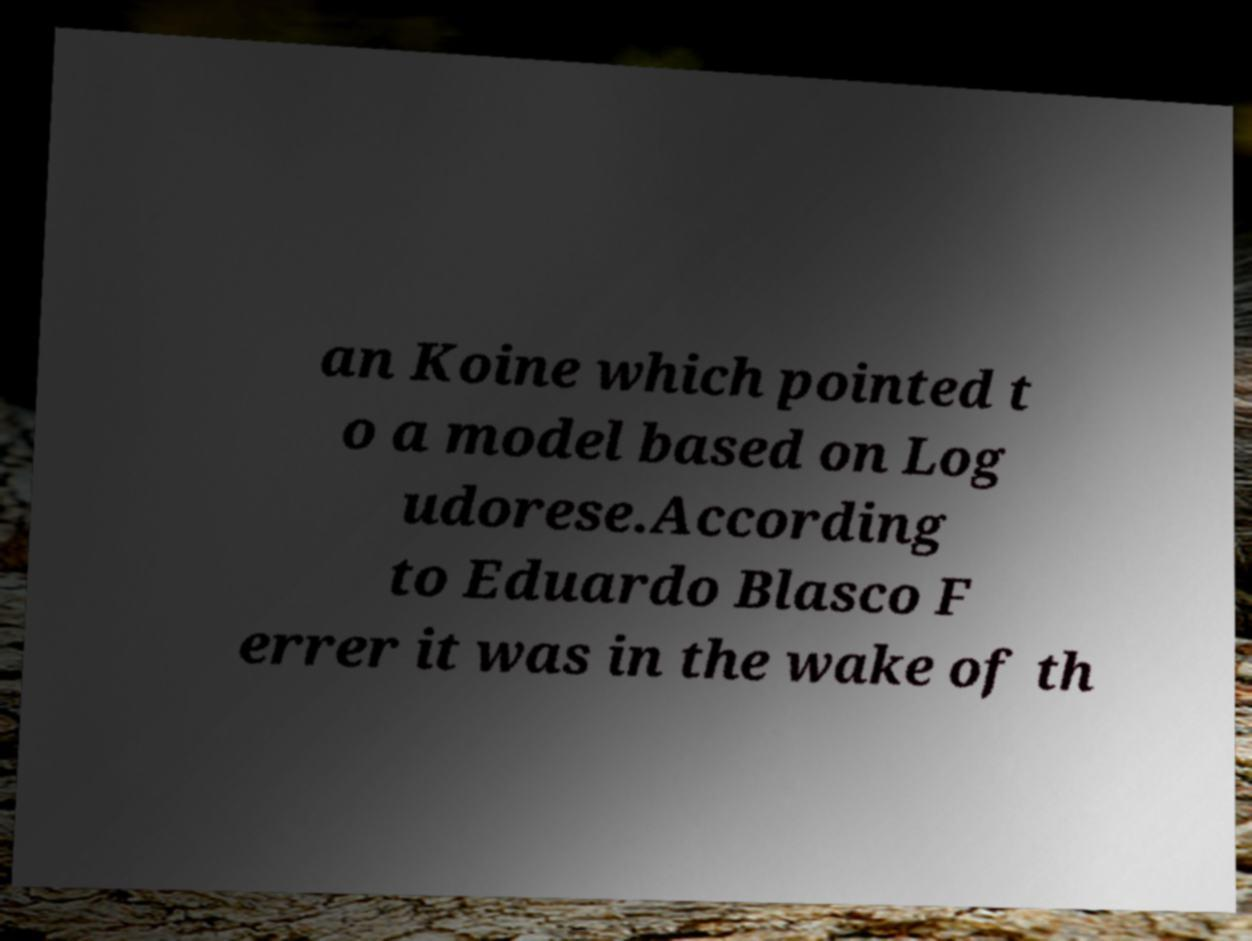I need the written content from this picture converted into text. Can you do that? an Koine which pointed t o a model based on Log udorese.According to Eduardo Blasco F errer it was in the wake of th 